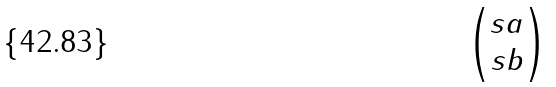<formula> <loc_0><loc_0><loc_500><loc_500>\begin{pmatrix} s a \\ s b \end{pmatrix}</formula> 